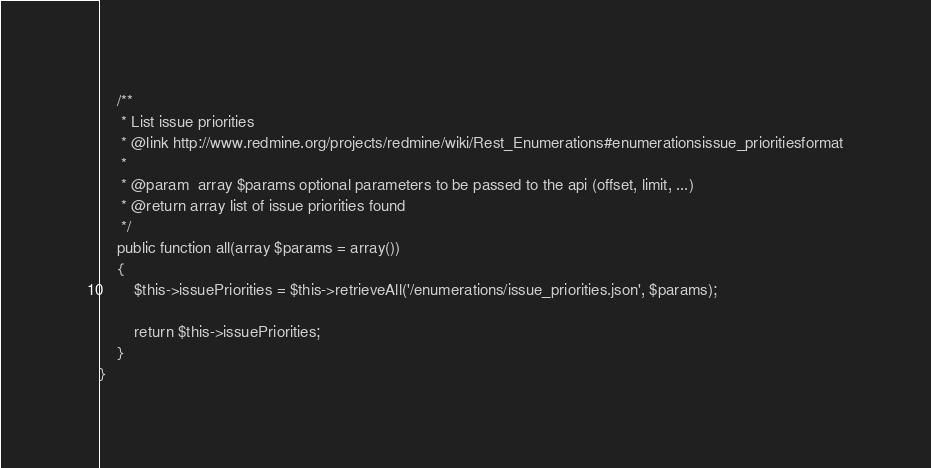<code> <loc_0><loc_0><loc_500><loc_500><_PHP_>
    /**
     * List issue priorities
     * @link http://www.redmine.org/projects/redmine/wiki/Rest_Enumerations#enumerationsissue_prioritiesformat
     *
     * @param  array $params optional parameters to be passed to the api (offset, limit, ...)
     * @return array list of issue priorities found
     */
    public function all(array $params = array())
    {
        $this->issuePriorities = $this->retrieveAll('/enumerations/issue_priorities.json', $params);

        return $this->issuePriorities;
    }
}
</code> 